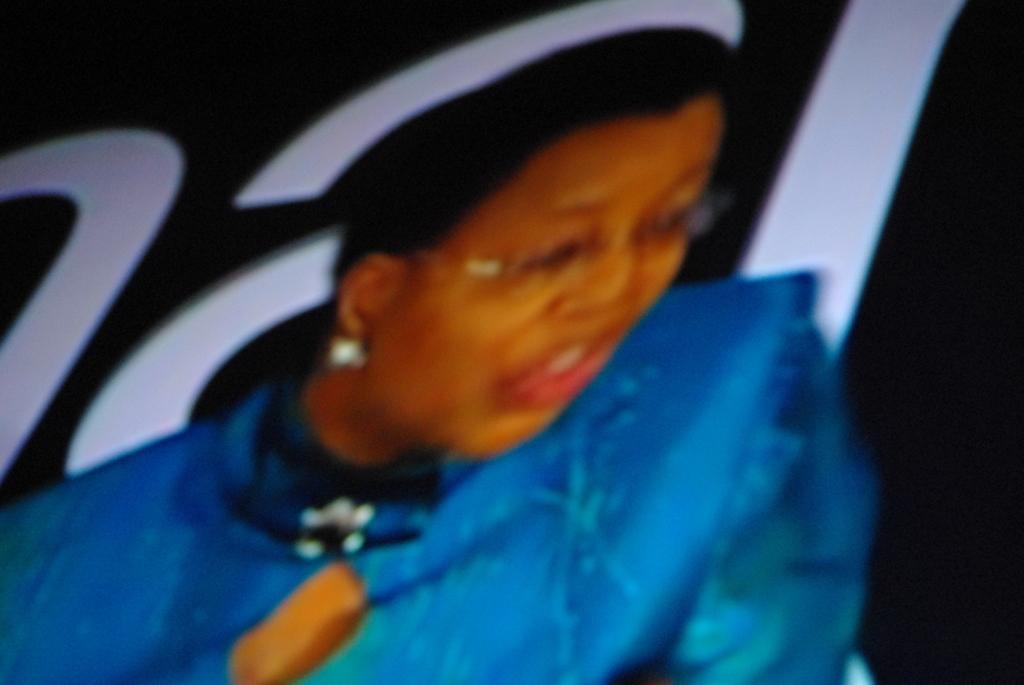Please provide a concise description of this image. In this image there is a person, there is text, the background of the image is dark. 